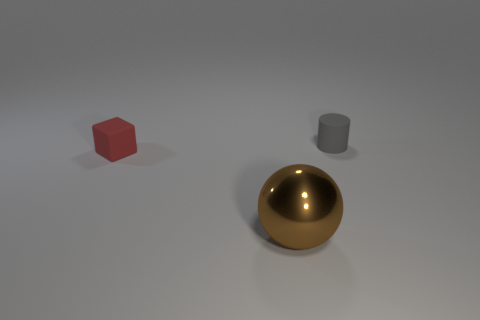Does the metal object have the same size as the gray matte thing?
Keep it short and to the point. No. How many spheres are either gray things or matte objects?
Offer a very short reply. 0. What number of big brown shiny things have the same shape as the red thing?
Offer a very short reply. 0. Are there more large shiny balls behind the tiny rubber cube than cubes on the right side of the tiny gray object?
Your answer should be compact. No. There is a large sphere that is in front of the small block; does it have the same color as the cube?
Offer a terse response. No. The metallic object is what size?
Provide a short and direct response. Large. There is a cylinder that is the same size as the matte cube; what is its material?
Provide a succinct answer. Rubber. There is a small object right of the brown shiny sphere; what is its color?
Make the answer very short. Gray. What number of yellow cylinders are there?
Your answer should be very brief. 0. Is there a metallic ball behind the matte thing that is behind the small rubber thing that is to the left of the gray thing?
Provide a succinct answer. No. 